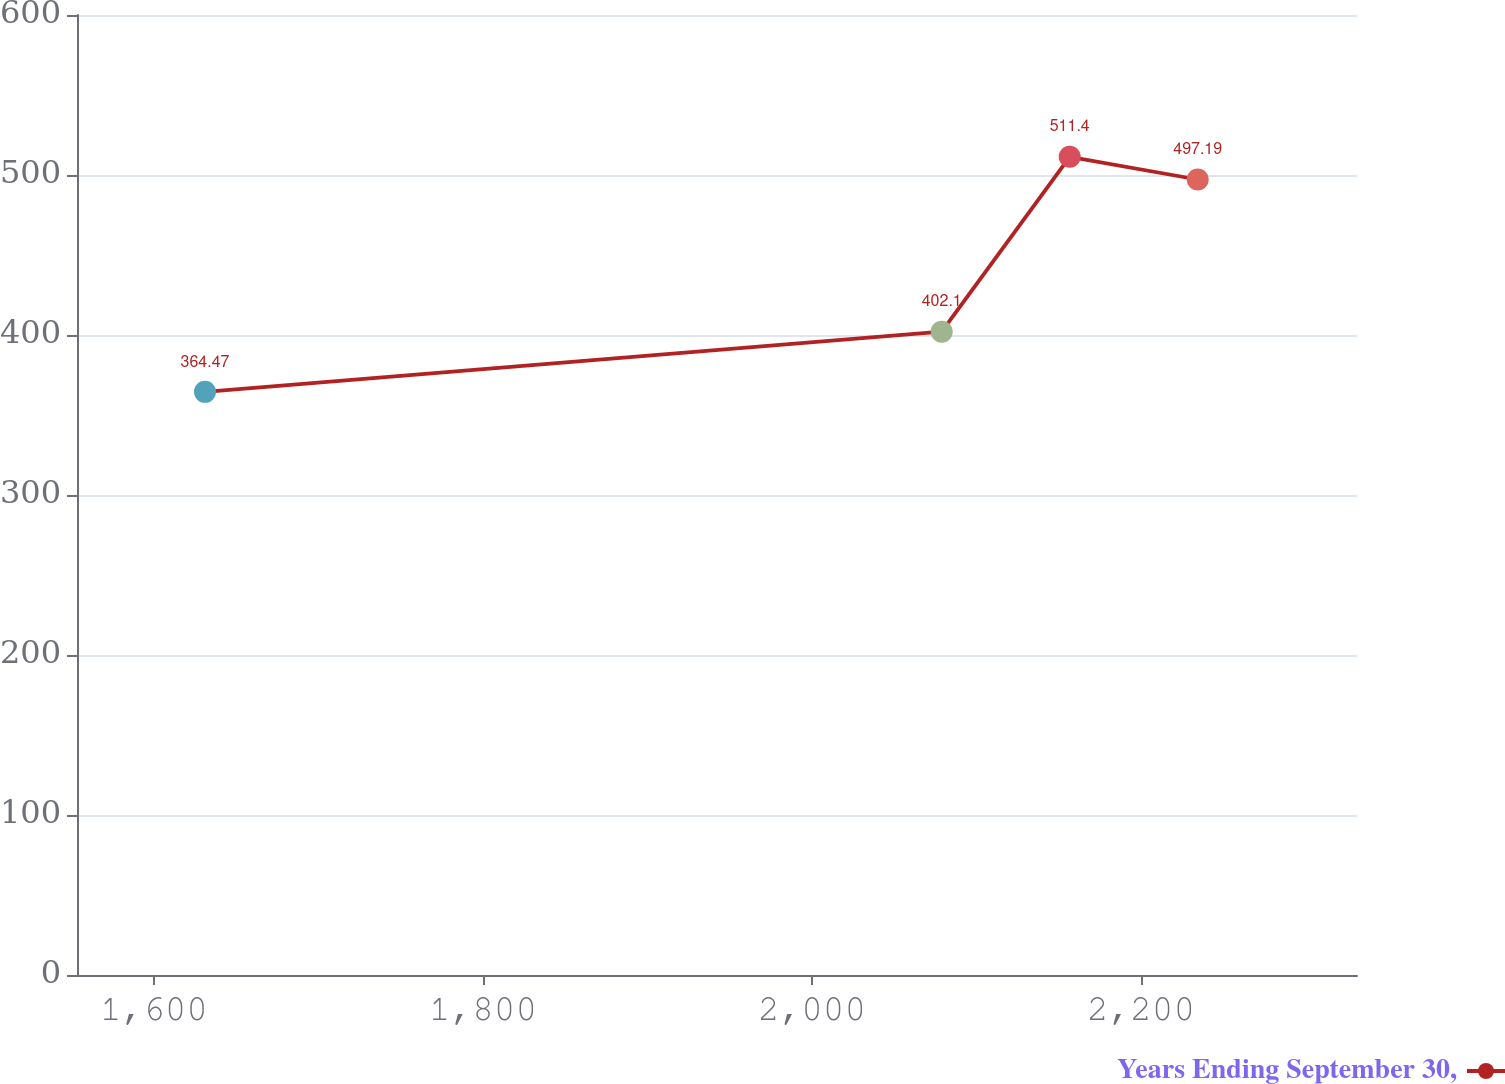<chart> <loc_0><loc_0><loc_500><loc_500><line_chart><ecel><fcel>Years Ending September 30,<nl><fcel>1631.02<fcel>364.47<nl><fcel>2078.82<fcel>402.1<nl><fcel>2156.62<fcel>511.4<nl><fcel>2234.42<fcel>497.19<nl><fcel>2409.05<fcel>387.89<nl></chart> 